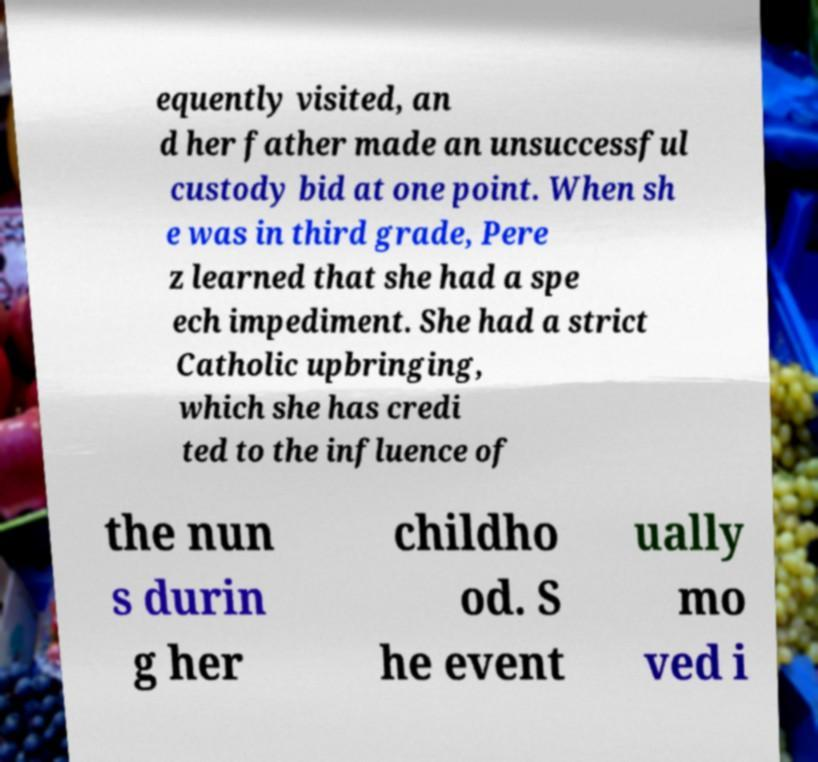Please identify and transcribe the text found in this image. equently visited, an d her father made an unsuccessful custody bid at one point. When sh e was in third grade, Pere z learned that she had a spe ech impediment. She had a strict Catholic upbringing, which she has credi ted to the influence of the nun s durin g her childho od. S he event ually mo ved i 